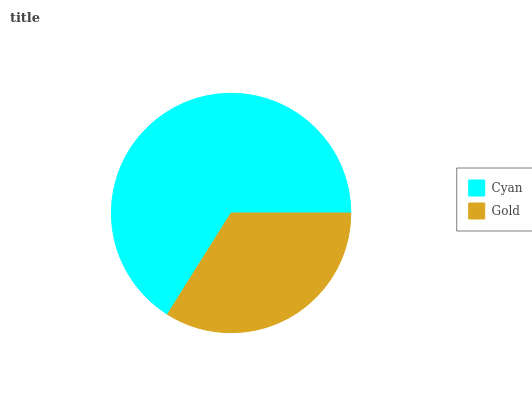Is Gold the minimum?
Answer yes or no. Yes. Is Cyan the maximum?
Answer yes or no. Yes. Is Gold the maximum?
Answer yes or no. No. Is Cyan greater than Gold?
Answer yes or no. Yes. Is Gold less than Cyan?
Answer yes or no. Yes. Is Gold greater than Cyan?
Answer yes or no. No. Is Cyan less than Gold?
Answer yes or no. No. Is Cyan the high median?
Answer yes or no. Yes. Is Gold the low median?
Answer yes or no. Yes. Is Gold the high median?
Answer yes or no. No. Is Cyan the low median?
Answer yes or no. No. 